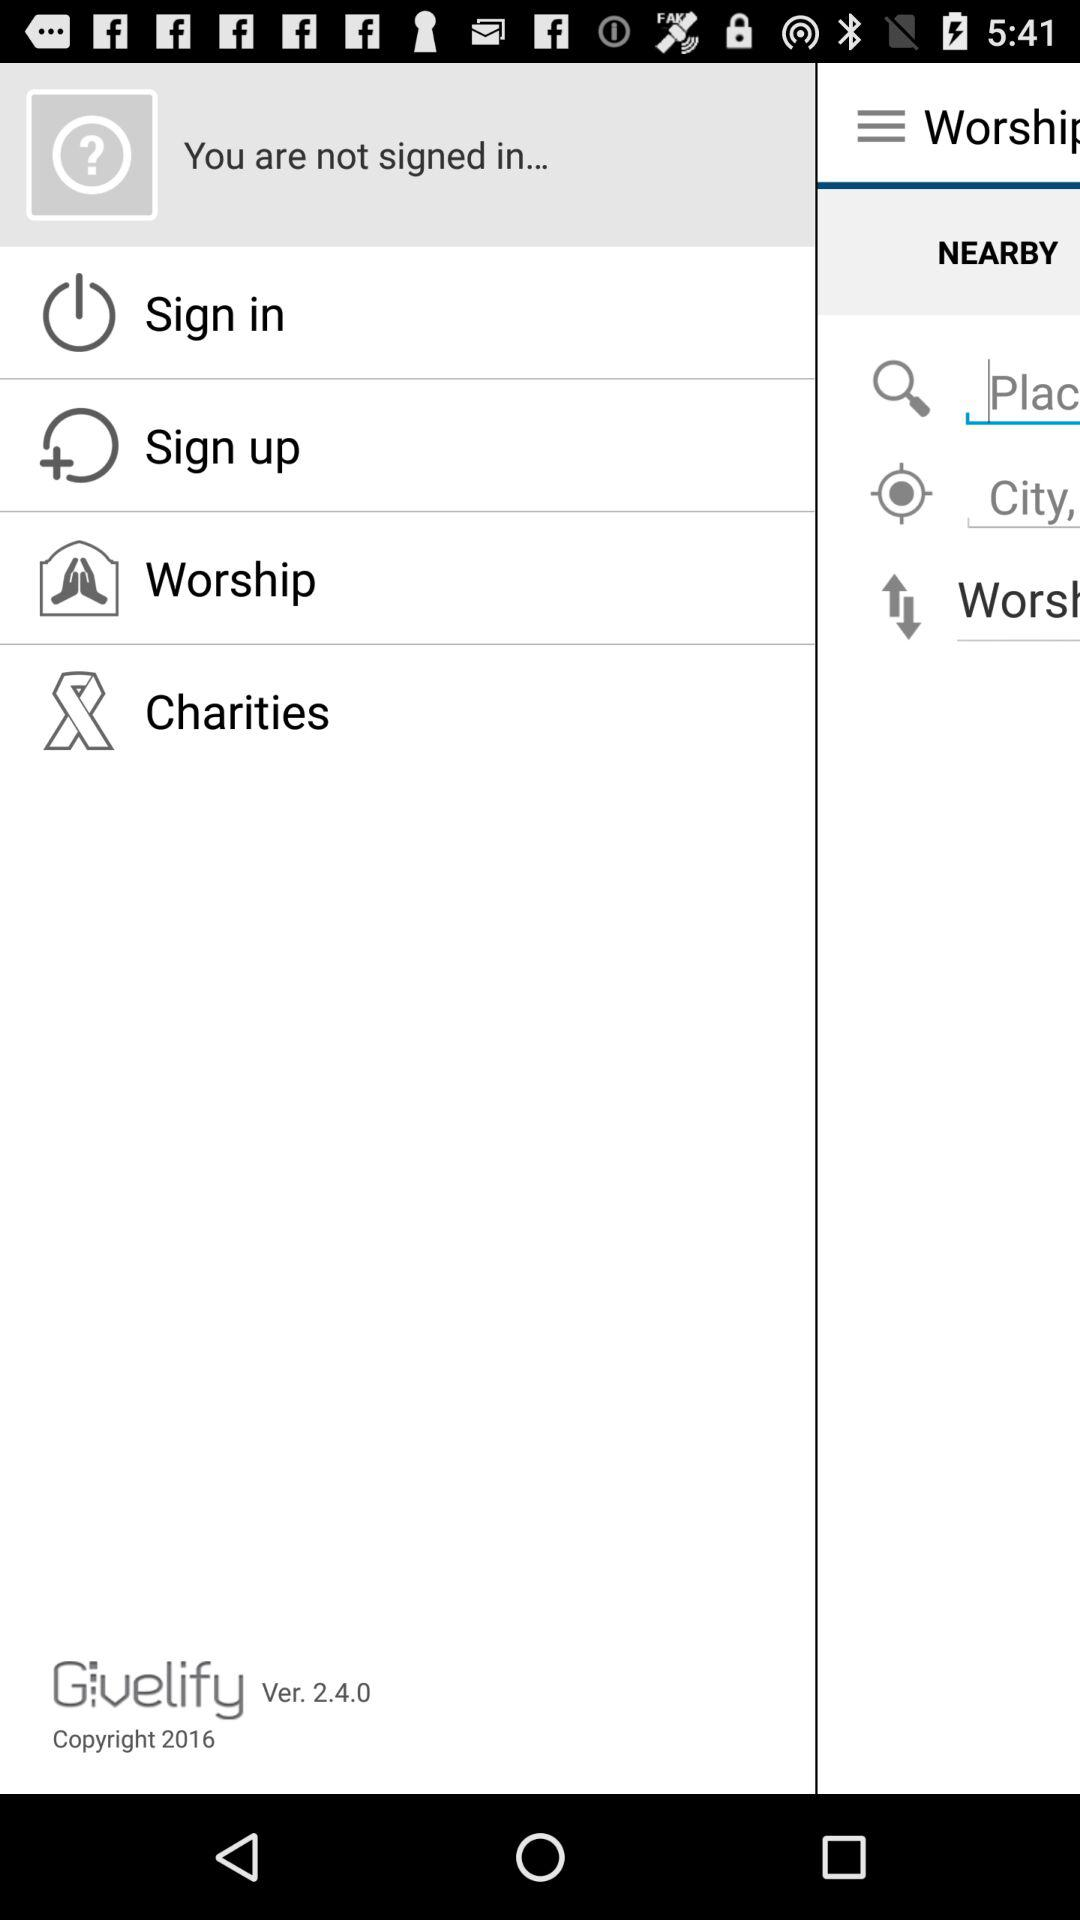What is the version of the application? The version is 2.4.0. 